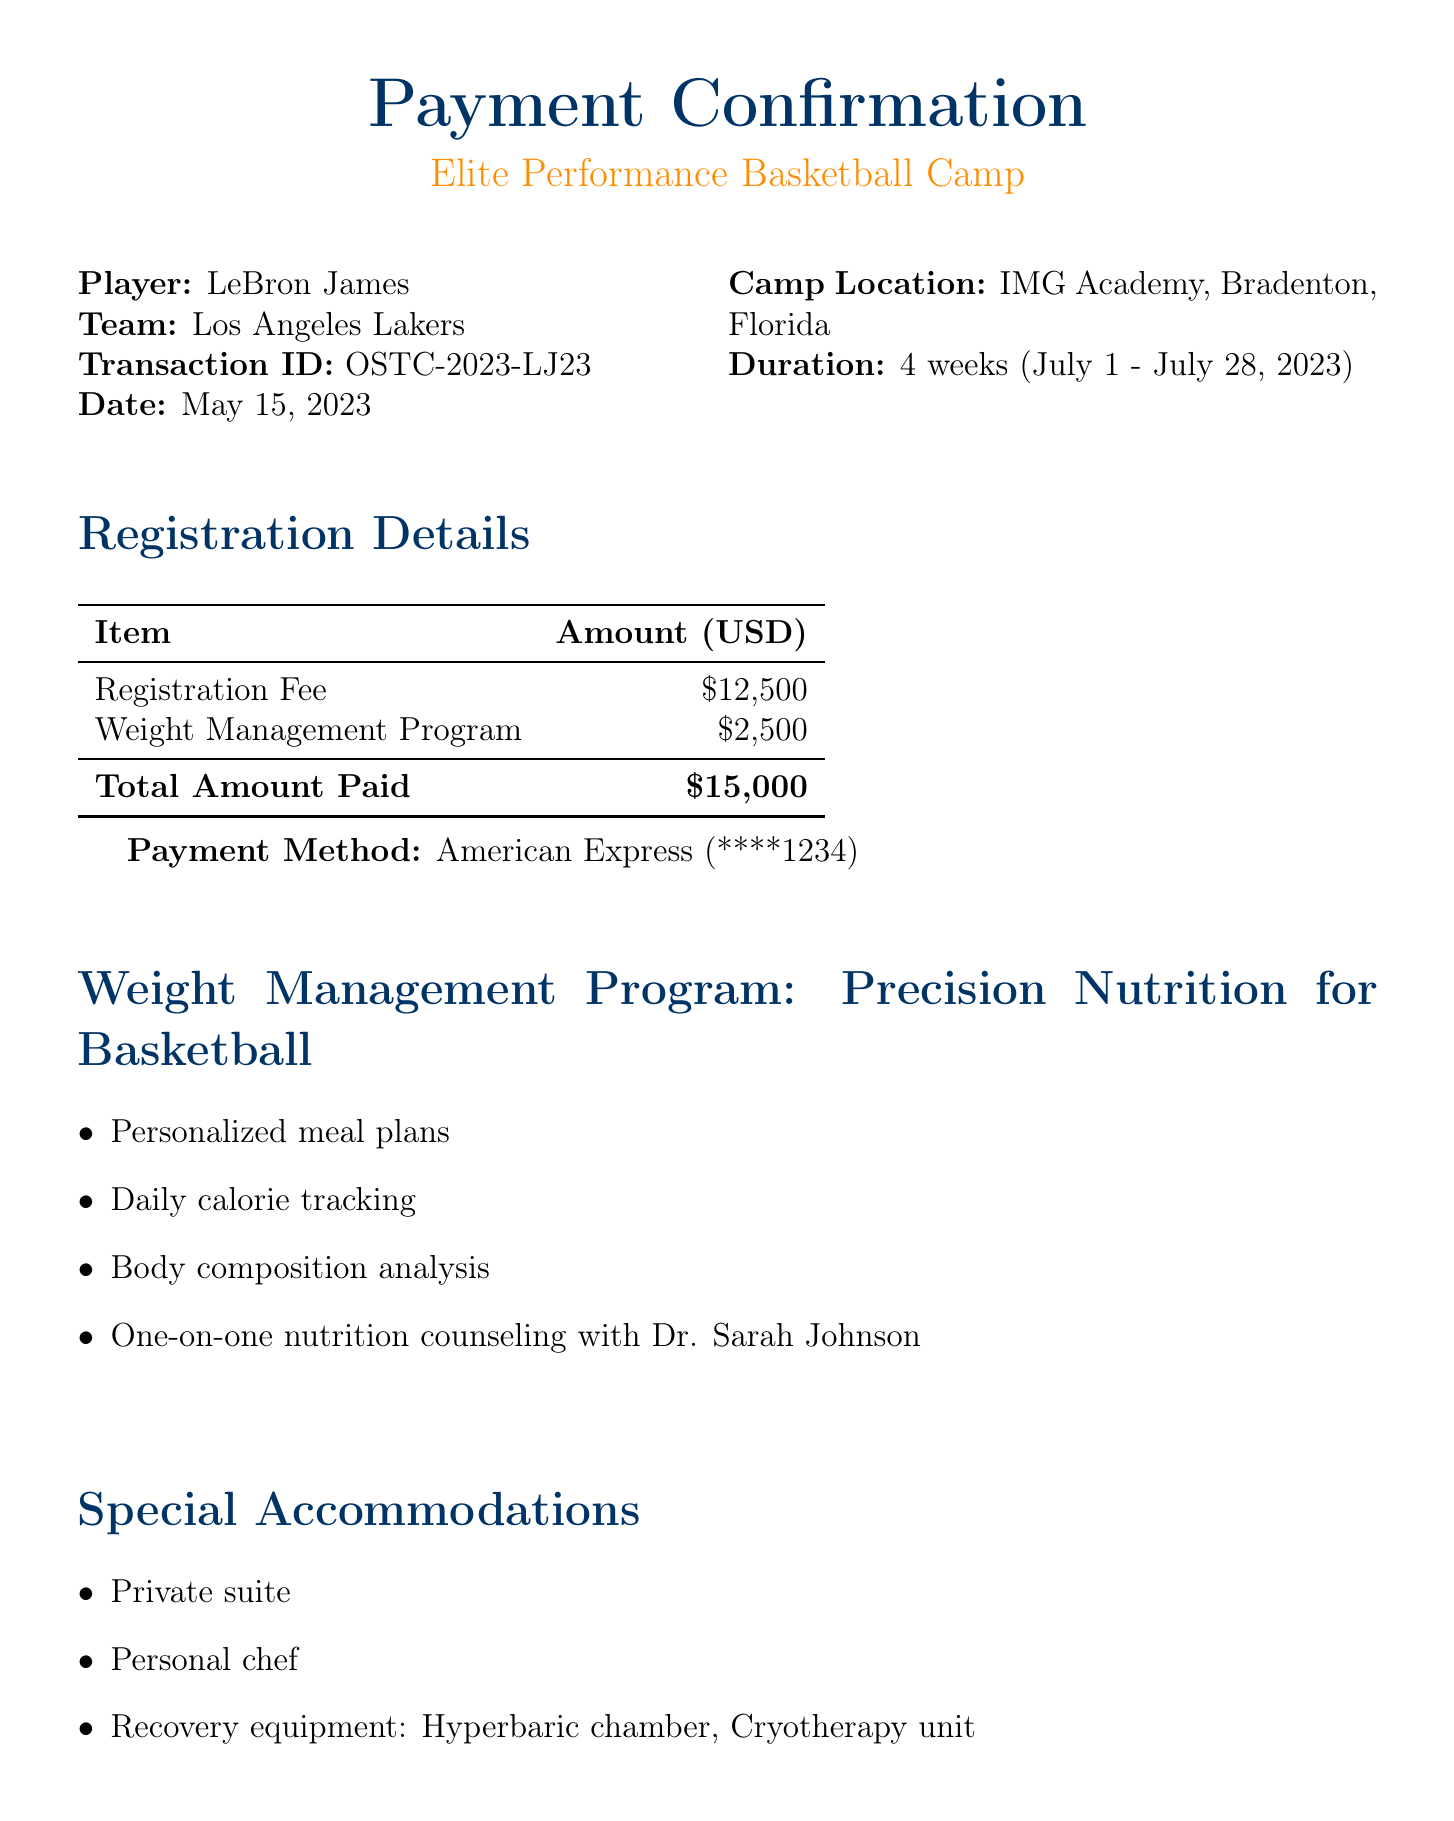What is the player's name? The player's name is mentioned in the document as LeBron James.
Answer: LeBron James What is the total amount paid? The total amount paid is explicitly stated in the document as $15,000.
Answer: $15,000 What is the duration of the training camp? The duration of the training camp can be found in the document as 4 weeks.
Answer: 4 weeks Who is the nutritionist for the weight management program? The nutritionist's name is provided in the weight management program section as Dr. Sarah Johnson.
Answer: Dr. Sarah Johnson What is the start date of the training camp? The start date is specified in the document as July 1, 2023.
Answer: July 1, 2023 What additional fee is associated with the weight management program? The document details an additional fee of $2,500 for the weight management program.
Answer: $2,500 What is the main focus of the weight management program? The weight management program is focused on Precision Nutrition for Basketball, which indicates specialization in nutrition for athletes.
Answer: Precision Nutrition for Basketball What facilities are included for recovery? Recovery facilities include Hyperbaric chamber and Cryotherapy unit, mentioned in the special accommodations section.
Answer: Hyperbaric chamber, Cryotherapy unit What is the cancellation policy for a full refund? The cancellation policy specifies the full refund deadline as June 1, 2023.
Answer: June 1, 2023 